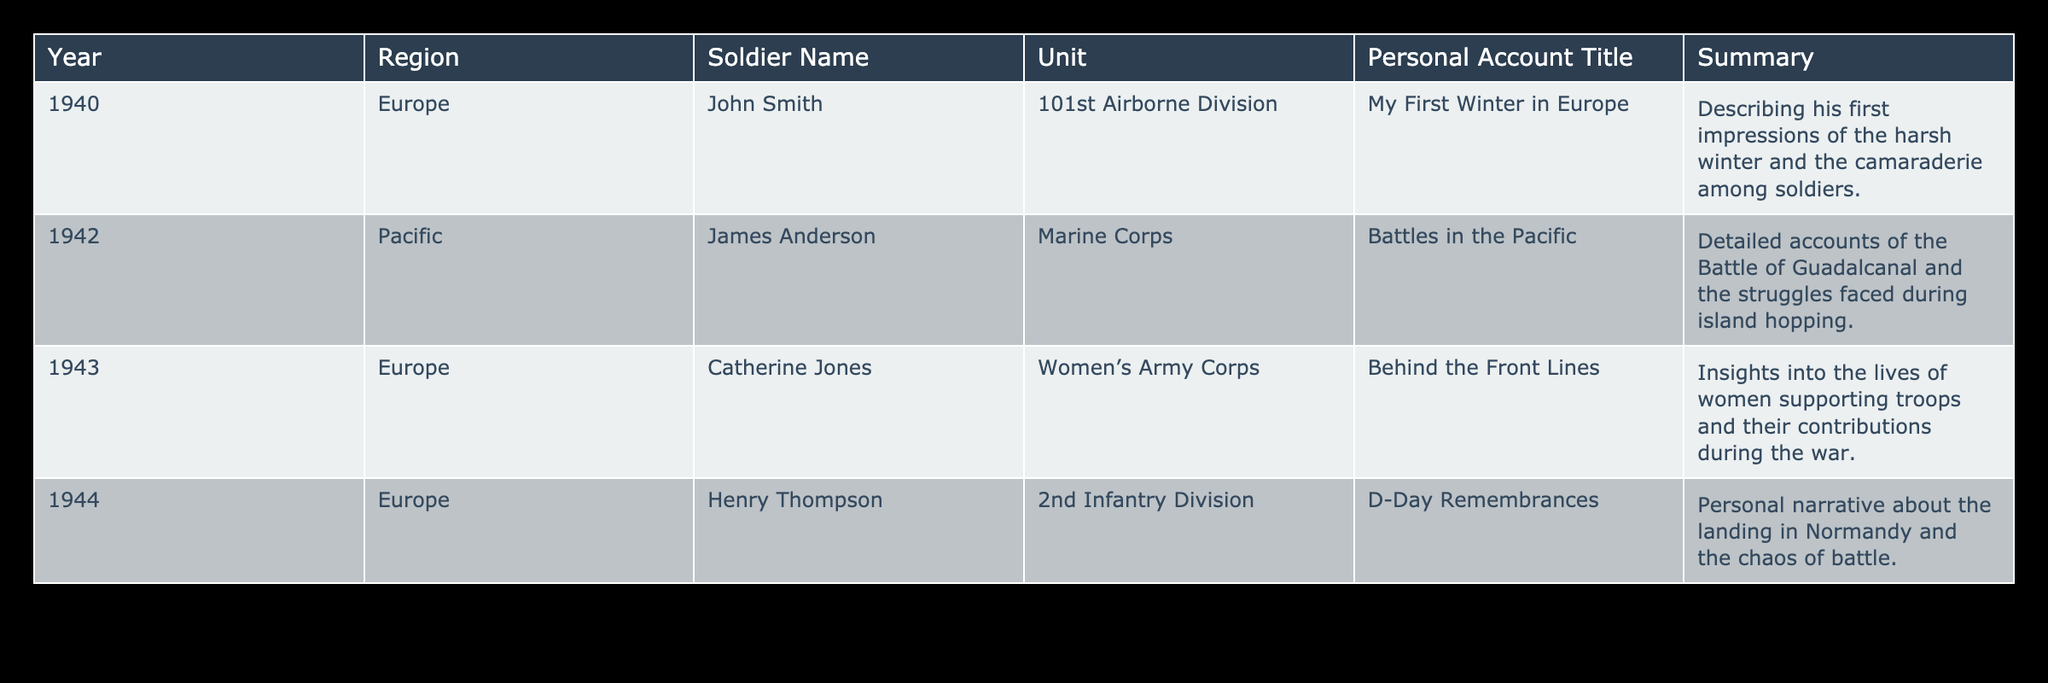What year did John Smith serve in Europe? John Smith's personal account indicates he served in the year 1940, as noted in the Year column of the table.
Answer: 1940 Which region is associated with James Anderson's account? The table lists James Anderson as serving in the Pacific region when he provided his personal account in 1942.
Answer: Pacific How many personal accounts are listed for the year 1944? According to the table, there is one personal account listed for the year 1944, specifically by Henry Thompson.
Answer: 1 Did any accounts focus on the contributions of women during WWII? Yes, Catherine Jones' account in 1943, listed under the Women’s Army Corps, specifically addresses the contributions of women during the war.
Answer: Yes What is the title of the personal account written by Henry Thompson? The title of Henry Thompson's personal account is "D-Day Remembrances," as noted in the Personal Account Title column.
Answer: D-Day Remembrances What is the time span of the accounts documented in the table? The accounts span from the year 1940 to 1944, indicating a total of five years of documented personal experiences related to WWII.
Answer: 5 years How many personal accounts are from Europe? There are three accounts from Europe as per the table—by John Smith, Catherine Jones, and Henry Thompson.
Answer: 3 Which soldier had the earliest documented account in the table? John Smith has the earliest documented account, which is from 1940, while all other accounts are from later years.
Answer: John Smith What is the average year of the personal accounts listed in the table? The years of the accounts are 1940, 1942, 1943, and 1944, summing these gives 1940 + 1942 + 1943 + 1944 = 7775; dividing by 4 gives an average year of 1943.75, which can be rounded to 1944.
Answer: 1944 